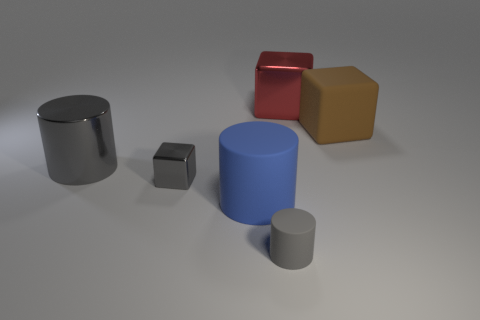There is a blue thing that is the same material as the brown thing; what is its shape?
Your response must be concise. Cylinder. There is a matte object that is on the right side of the big rubber cylinder and in front of the big brown rubber block; what is its color?
Give a very brief answer. Gray. Does the block left of the large red thing have the same material as the big brown object?
Keep it short and to the point. No. Is the number of large rubber cylinders left of the large shiny cylinder less than the number of small gray matte objects?
Give a very brief answer. Yes. Is there a blue cylinder made of the same material as the brown thing?
Your answer should be compact. Yes. There is a gray shiny block; is its size the same as the gray cylinder that is in front of the large gray cylinder?
Provide a succinct answer. Yes. Are there any matte cylinders that have the same color as the metal cylinder?
Ensure brevity in your answer.  Yes. Does the red block have the same material as the big brown thing?
Offer a terse response. No. How many large gray things are on the right side of the big blue object?
Your answer should be very brief. 0. What material is the cylinder that is behind the gray rubber cylinder and in front of the large gray metal cylinder?
Keep it short and to the point. Rubber. 